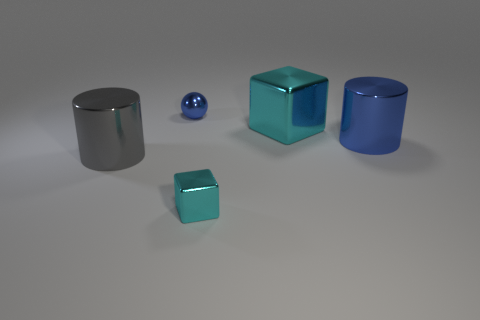Add 5 gray cylinders. How many objects exist? 10 Subtract all balls. How many objects are left? 4 Subtract all small blue metallic objects. Subtract all tiny blue objects. How many objects are left? 3 Add 5 small metal cubes. How many small metal cubes are left? 6 Add 3 gray balls. How many gray balls exist? 3 Subtract 0 gray cubes. How many objects are left? 5 Subtract 1 spheres. How many spheres are left? 0 Subtract all green balls. Subtract all green cubes. How many balls are left? 1 Subtract all blue spheres. How many brown cylinders are left? 0 